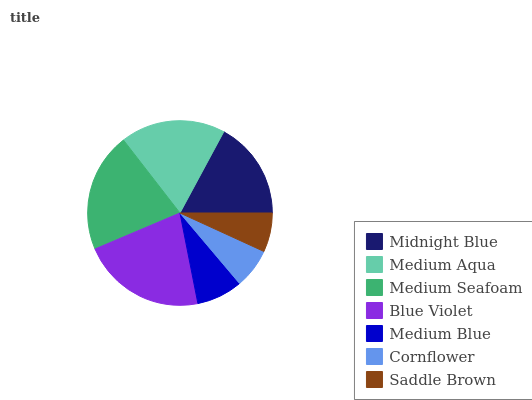Is Saddle Brown the minimum?
Answer yes or no. Yes. Is Blue Violet the maximum?
Answer yes or no. Yes. Is Medium Aqua the minimum?
Answer yes or no. No. Is Medium Aqua the maximum?
Answer yes or no. No. Is Medium Aqua greater than Midnight Blue?
Answer yes or no. Yes. Is Midnight Blue less than Medium Aqua?
Answer yes or no. Yes. Is Midnight Blue greater than Medium Aqua?
Answer yes or no. No. Is Medium Aqua less than Midnight Blue?
Answer yes or no. No. Is Midnight Blue the high median?
Answer yes or no. Yes. Is Midnight Blue the low median?
Answer yes or no. Yes. Is Medium Blue the high median?
Answer yes or no. No. Is Medium Blue the low median?
Answer yes or no. No. 